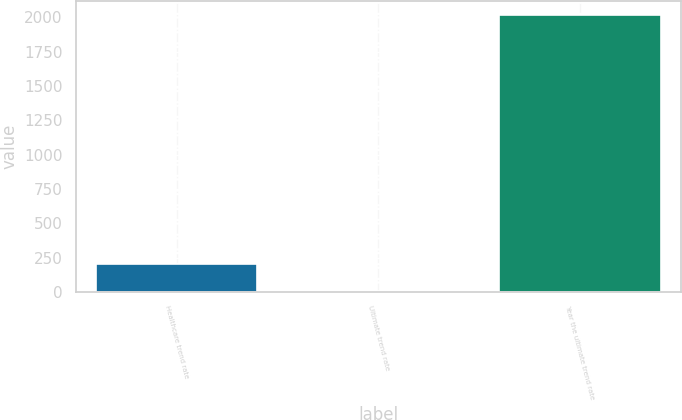Convert chart to OTSL. <chart><loc_0><loc_0><loc_500><loc_500><bar_chart><fcel>Healthcare trend rate<fcel>Ultimate trend rate<fcel>Year the ultimate trend rate<nl><fcel>206.4<fcel>5<fcel>2019<nl></chart> 